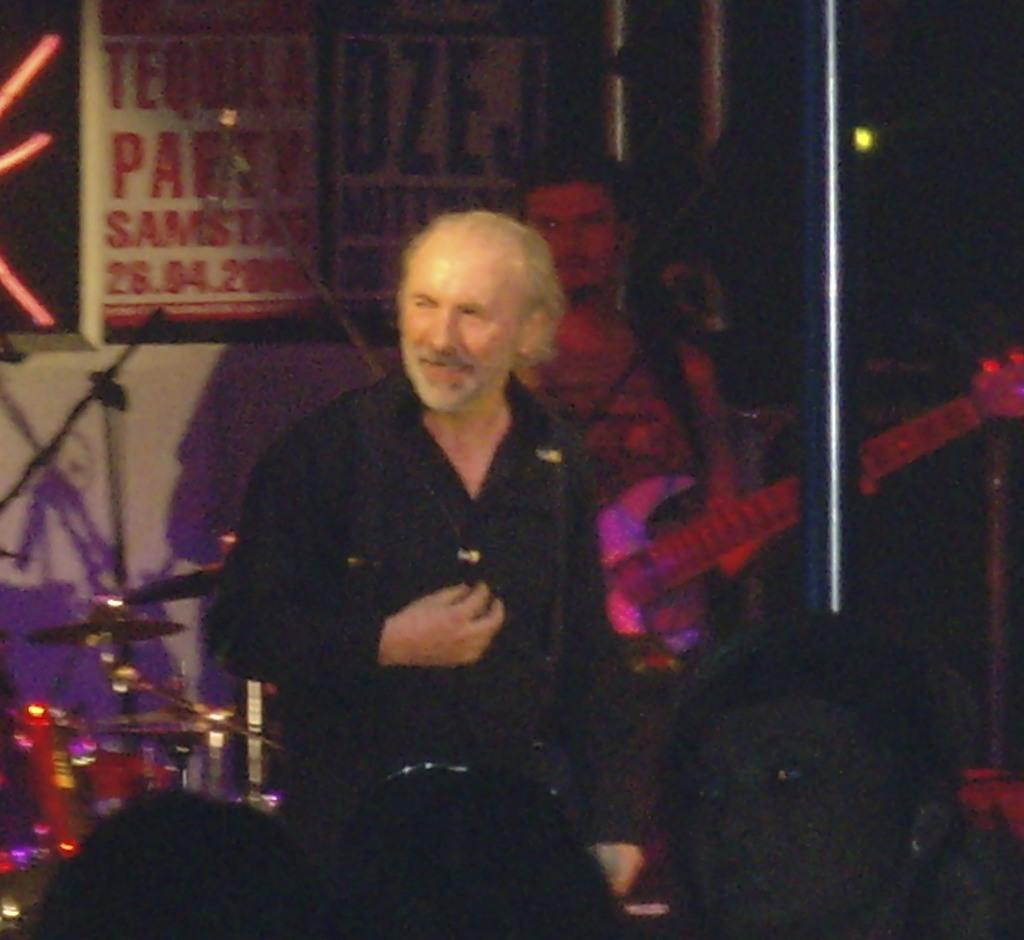How many people are visible in the image? There are two persons standing in front in the image, and one person at the back holding a guitar. What is the person at the back doing? The person at the back is holding a guitar. What can be seen in the background of the image? There is a banner, a pole, a light, and some musical instruments in the background of the image. How does the scarecrow help the musicians in the image? There is no scarecrow present in the image. What type of wash is being used to clean the musical instruments in the image? There is no indication of any wash being used to clean the musical instruments in the image. 